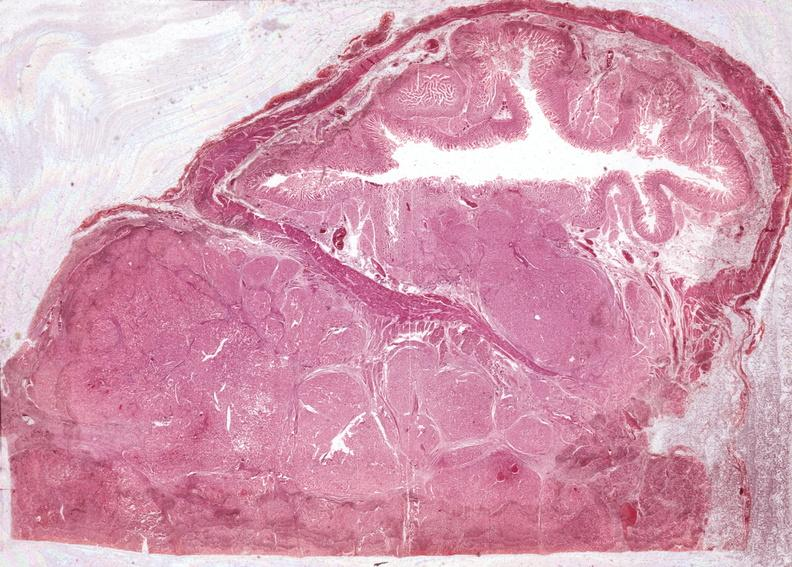does micrognathia triploid fetus show islet cell carcinoma?
Answer the question using a single word or phrase. No 